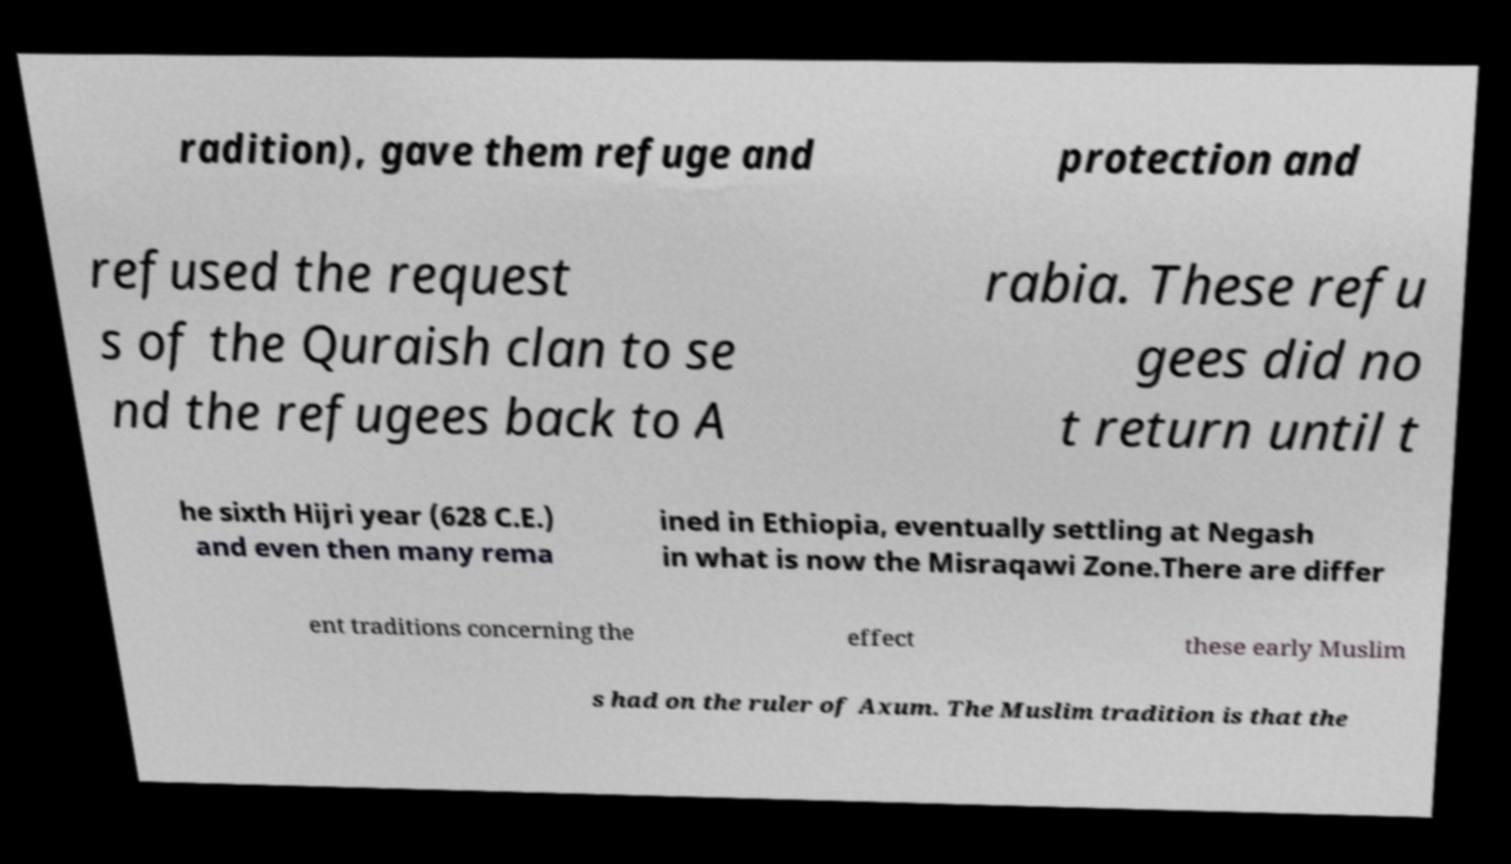Could you extract and type out the text from this image? radition), gave them refuge and protection and refused the request s of the Quraish clan to se nd the refugees back to A rabia. These refu gees did no t return until t he sixth Hijri year (628 C.E.) and even then many rema ined in Ethiopia, eventually settling at Negash in what is now the Misraqawi Zone.There are differ ent traditions concerning the effect these early Muslim s had on the ruler of Axum. The Muslim tradition is that the 